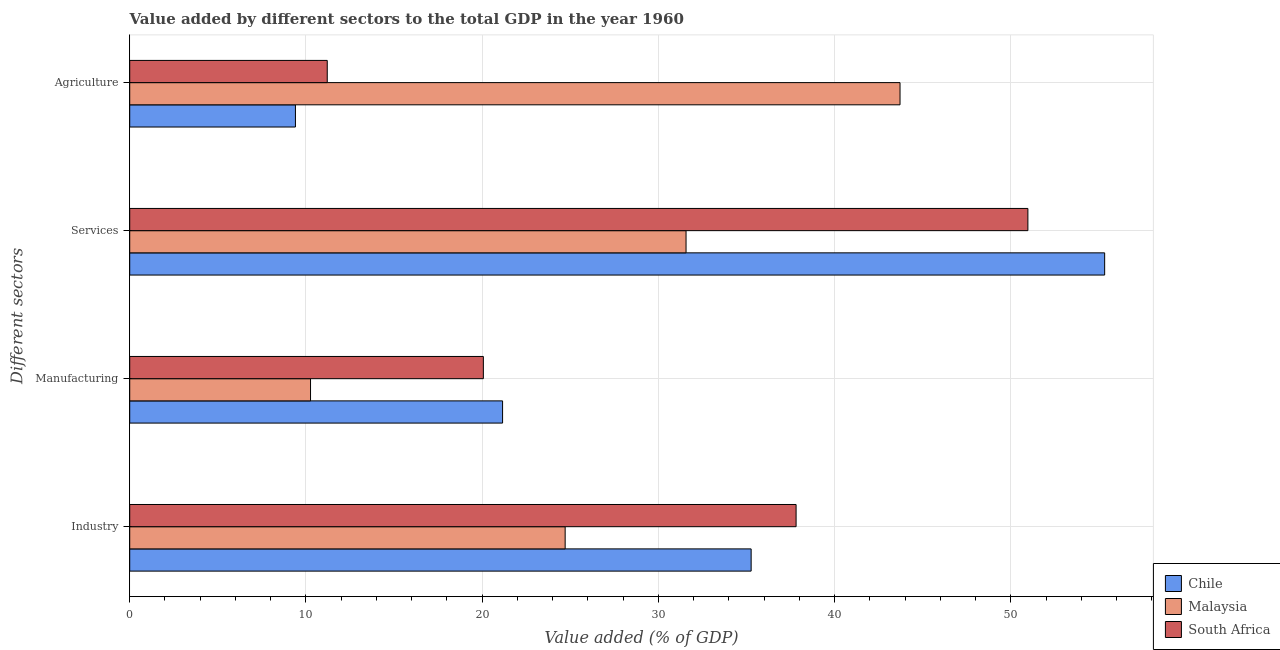How many different coloured bars are there?
Make the answer very short. 3. How many groups of bars are there?
Make the answer very short. 4. Are the number of bars on each tick of the Y-axis equal?
Offer a terse response. Yes. How many bars are there on the 3rd tick from the top?
Your answer should be very brief. 3. How many bars are there on the 4th tick from the bottom?
Provide a succinct answer. 3. What is the label of the 2nd group of bars from the top?
Ensure brevity in your answer.  Services. What is the value added by agricultural sector in Chile?
Make the answer very short. 9.4. Across all countries, what is the maximum value added by services sector?
Your answer should be compact. 55.33. Across all countries, what is the minimum value added by manufacturing sector?
Give a very brief answer. 10.26. In which country was the value added by agricultural sector maximum?
Provide a short and direct response. Malaysia. What is the total value added by manufacturing sector in the graph?
Keep it short and to the point. 51.49. What is the difference between the value added by manufacturing sector in Chile and that in Malaysia?
Your answer should be compact. 10.9. What is the difference between the value added by industrial sector in Malaysia and the value added by manufacturing sector in South Africa?
Provide a short and direct response. 4.64. What is the average value added by services sector per country?
Offer a terse response. 45.96. What is the difference between the value added by industrial sector and value added by agricultural sector in Malaysia?
Ensure brevity in your answer.  -19. In how many countries, is the value added by industrial sector greater than 48 %?
Provide a short and direct response. 0. What is the ratio of the value added by services sector in Chile to that in South Africa?
Make the answer very short. 1.09. Is the difference between the value added by manufacturing sector in South Africa and Malaysia greater than the difference between the value added by industrial sector in South Africa and Malaysia?
Provide a succinct answer. No. What is the difference between the highest and the second highest value added by agricultural sector?
Offer a terse response. 32.51. What is the difference between the highest and the lowest value added by services sector?
Make the answer very short. 23.76. Is the sum of the value added by agricultural sector in Malaysia and South Africa greater than the maximum value added by industrial sector across all countries?
Your response must be concise. Yes. What does the 3rd bar from the bottom in Services represents?
Keep it short and to the point. South Africa. Is it the case that in every country, the sum of the value added by industrial sector and value added by manufacturing sector is greater than the value added by services sector?
Make the answer very short. Yes. How many bars are there?
Keep it short and to the point. 12. Are all the bars in the graph horizontal?
Keep it short and to the point. Yes. How many countries are there in the graph?
Your response must be concise. 3. Does the graph contain grids?
Make the answer very short. Yes. How many legend labels are there?
Ensure brevity in your answer.  3. What is the title of the graph?
Ensure brevity in your answer.  Value added by different sectors to the total GDP in the year 1960. Does "Switzerland" appear as one of the legend labels in the graph?
Offer a very short reply. No. What is the label or title of the X-axis?
Ensure brevity in your answer.  Value added (% of GDP). What is the label or title of the Y-axis?
Keep it short and to the point. Different sectors. What is the Value added (% of GDP) in Chile in Industry?
Offer a very short reply. 35.27. What is the Value added (% of GDP) of Malaysia in Industry?
Your answer should be very brief. 24.71. What is the Value added (% of GDP) in South Africa in Industry?
Make the answer very short. 37.82. What is the Value added (% of GDP) in Chile in Manufacturing?
Your response must be concise. 21.16. What is the Value added (% of GDP) in Malaysia in Manufacturing?
Ensure brevity in your answer.  10.26. What is the Value added (% of GDP) in South Africa in Manufacturing?
Make the answer very short. 20.07. What is the Value added (% of GDP) of Chile in Services?
Offer a very short reply. 55.33. What is the Value added (% of GDP) in Malaysia in Services?
Provide a short and direct response. 31.57. What is the Value added (% of GDP) in South Africa in Services?
Provide a succinct answer. 50.97. What is the Value added (% of GDP) of Chile in Agriculture?
Provide a succinct answer. 9.4. What is the Value added (% of GDP) of Malaysia in Agriculture?
Make the answer very short. 43.72. What is the Value added (% of GDP) in South Africa in Agriculture?
Your answer should be compact. 11.21. Across all Different sectors, what is the maximum Value added (% of GDP) in Chile?
Provide a succinct answer. 55.33. Across all Different sectors, what is the maximum Value added (% of GDP) in Malaysia?
Your response must be concise. 43.72. Across all Different sectors, what is the maximum Value added (% of GDP) of South Africa?
Your response must be concise. 50.97. Across all Different sectors, what is the minimum Value added (% of GDP) in Chile?
Make the answer very short. 9.4. Across all Different sectors, what is the minimum Value added (% of GDP) of Malaysia?
Provide a succinct answer. 10.26. Across all Different sectors, what is the minimum Value added (% of GDP) in South Africa?
Offer a terse response. 11.21. What is the total Value added (% of GDP) in Chile in the graph?
Your answer should be very brief. 121.16. What is the total Value added (% of GDP) of Malaysia in the graph?
Your answer should be very brief. 110.26. What is the total Value added (% of GDP) in South Africa in the graph?
Keep it short and to the point. 120.07. What is the difference between the Value added (% of GDP) in Chile in Industry and that in Manufacturing?
Keep it short and to the point. 14.11. What is the difference between the Value added (% of GDP) in Malaysia in Industry and that in Manufacturing?
Ensure brevity in your answer.  14.45. What is the difference between the Value added (% of GDP) of South Africa in Industry and that in Manufacturing?
Offer a terse response. 17.75. What is the difference between the Value added (% of GDP) of Chile in Industry and that in Services?
Your response must be concise. -20.06. What is the difference between the Value added (% of GDP) in Malaysia in Industry and that in Services?
Provide a succinct answer. -6.86. What is the difference between the Value added (% of GDP) in South Africa in Industry and that in Services?
Your answer should be very brief. -13.15. What is the difference between the Value added (% of GDP) of Chile in Industry and that in Agriculture?
Provide a succinct answer. 25.86. What is the difference between the Value added (% of GDP) of Malaysia in Industry and that in Agriculture?
Your answer should be compact. -19. What is the difference between the Value added (% of GDP) in South Africa in Industry and that in Agriculture?
Offer a terse response. 26.61. What is the difference between the Value added (% of GDP) in Chile in Manufacturing and that in Services?
Your answer should be compact. -34.17. What is the difference between the Value added (% of GDP) in Malaysia in Manufacturing and that in Services?
Ensure brevity in your answer.  -21.31. What is the difference between the Value added (% of GDP) in South Africa in Manufacturing and that in Services?
Offer a terse response. -30.9. What is the difference between the Value added (% of GDP) of Chile in Manufacturing and that in Agriculture?
Offer a terse response. 11.76. What is the difference between the Value added (% of GDP) of Malaysia in Manufacturing and that in Agriculture?
Ensure brevity in your answer.  -33.45. What is the difference between the Value added (% of GDP) in South Africa in Manufacturing and that in Agriculture?
Give a very brief answer. 8.86. What is the difference between the Value added (% of GDP) in Chile in Services and that in Agriculture?
Provide a succinct answer. 45.92. What is the difference between the Value added (% of GDP) of Malaysia in Services and that in Agriculture?
Your response must be concise. -12.14. What is the difference between the Value added (% of GDP) in South Africa in Services and that in Agriculture?
Give a very brief answer. 39.76. What is the difference between the Value added (% of GDP) in Chile in Industry and the Value added (% of GDP) in Malaysia in Manufacturing?
Your answer should be compact. 25.01. What is the difference between the Value added (% of GDP) of Chile in Industry and the Value added (% of GDP) of South Africa in Manufacturing?
Keep it short and to the point. 15.2. What is the difference between the Value added (% of GDP) of Malaysia in Industry and the Value added (% of GDP) of South Africa in Manufacturing?
Ensure brevity in your answer.  4.64. What is the difference between the Value added (% of GDP) in Chile in Industry and the Value added (% of GDP) in Malaysia in Services?
Your answer should be very brief. 3.69. What is the difference between the Value added (% of GDP) in Chile in Industry and the Value added (% of GDP) in South Africa in Services?
Give a very brief answer. -15.71. What is the difference between the Value added (% of GDP) in Malaysia in Industry and the Value added (% of GDP) in South Africa in Services?
Provide a succinct answer. -26.26. What is the difference between the Value added (% of GDP) of Chile in Industry and the Value added (% of GDP) of Malaysia in Agriculture?
Make the answer very short. -8.45. What is the difference between the Value added (% of GDP) of Chile in Industry and the Value added (% of GDP) of South Africa in Agriculture?
Keep it short and to the point. 24.06. What is the difference between the Value added (% of GDP) in Malaysia in Industry and the Value added (% of GDP) in South Africa in Agriculture?
Offer a very short reply. 13.5. What is the difference between the Value added (% of GDP) of Chile in Manufacturing and the Value added (% of GDP) of Malaysia in Services?
Offer a very short reply. -10.41. What is the difference between the Value added (% of GDP) in Chile in Manufacturing and the Value added (% of GDP) in South Africa in Services?
Your response must be concise. -29.81. What is the difference between the Value added (% of GDP) in Malaysia in Manufacturing and the Value added (% of GDP) in South Africa in Services?
Offer a very short reply. -40.71. What is the difference between the Value added (% of GDP) in Chile in Manufacturing and the Value added (% of GDP) in Malaysia in Agriculture?
Make the answer very short. -22.56. What is the difference between the Value added (% of GDP) in Chile in Manufacturing and the Value added (% of GDP) in South Africa in Agriculture?
Offer a very short reply. 9.95. What is the difference between the Value added (% of GDP) in Malaysia in Manufacturing and the Value added (% of GDP) in South Africa in Agriculture?
Give a very brief answer. -0.95. What is the difference between the Value added (% of GDP) of Chile in Services and the Value added (% of GDP) of Malaysia in Agriculture?
Offer a terse response. 11.61. What is the difference between the Value added (% of GDP) of Chile in Services and the Value added (% of GDP) of South Africa in Agriculture?
Your response must be concise. 44.12. What is the difference between the Value added (% of GDP) of Malaysia in Services and the Value added (% of GDP) of South Africa in Agriculture?
Your answer should be very brief. 20.36. What is the average Value added (% of GDP) in Chile per Different sectors?
Give a very brief answer. 30.29. What is the average Value added (% of GDP) in Malaysia per Different sectors?
Offer a very short reply. 27.57. What is the average Value added (% of GDP) in South Africa per Different sectors?
Keep it short and to the point. 30.02. What is the difference between the Value added (% of GDP) of Chile and Value added (% of GDP) of Malaysia in Industry?
Keep it short and to the point. 10.56. What is the difference between the Value added (% of GDP) in Chile and Value added (% of GDP) in South Africa in Industry?
Give a very brief answer. -2.55. What is the difference between the Value added (% of GDP) of Malaysia and Value added (% of GDP) of South Africa in Industry?
Your answer should be compact. -13.11. What is the difference between the Value added (% of GDP) of Chile and Value added (% of GDP) of Malaysia in Manufacturing?
Give a very brief answer. 10.9. What is the difference between the Value added (% of GDP) in Chile and Value added (% of GDP) in South Africa in Manufacturing?
Your response must be concise. 1.09. What is the difference between the Value added (% of GDP) of Malaysia and Value added (% of GDP) of South Africa in Manufacturing?
Your response must be concise. -9.81. What is the difference between the Value added (% of GDP) of Chile and Value added (% of GDP) of Malaysia in Services?
Your response must be concise. 23.76. What is the difference between the Value added (% of GDP) of Chile and Value added (% of GDP) of South Africa in Services?
Make the answer very short. 4.36. What is the difference between the Value added (% of GDP) of Malaysia and Value added (% of GDP) of South Africa in Services?
Ensure brevity in your answer.  -19.4. What is the difference between the Value added (% of GDP) of Chile and Value added (% of GDP) of Malaysia in Agriculture?
Your answer should be very brief. -34.31. What is the difference between the Value added (% of GDP) in Chile and Value added (% of GDP) in South Africa in Agriculture?
Provide a succinct answer. -1.81. What is the difference between the Value added (% of GDP) of Malaysia and Value added (% of GDP) of South Africa in Agriculture?
Your response must be concise. 32.51. What is the ratio of the Value added (% of GDP) in Malaysia in Industry to that in Manufacturing?
Offer a terse response. 2.41. What is the ratio of the Value added (% of GDP) of South Africa in Industry to that in Manufacturing?
Ensure brevity in your answer.  1.88. What is the ratio of the Value added (% of GDP) in Chile in Industry to that in Services?
Make the answer very short. 0.64. What is the ratio of the Value added (% of GDP) in Malaysia in Industry to that in Services?
Offer a terse response. 0.78. What is the ratio of the Value added (% of GDP) in South Africa in Industry to that in Services?
Provide a short and direct response. 0.74. What is the ratio of the Value added (% of GDP) of Chile in Industry to that in Agriculture?
Keep it short and to the point. 3.75. What is the ratio of the Value added (% of GDP) in Malaysia in Industry to that in Agriculture?
Keep it short and to the point. 0.57. What is the ratio of the Value added (% of GDP) of South Africa in Industry to that in Agriculture?
Provide a short and direct response. 3.37. What is the ratio of the Value added (% of GDP) of Chile in Manufacturing to that in Services?
Your answer should be compact. 0.38. What is the ratio of the Value added (% of GDP) of Malaysia in Manufacturing to that in Services?
Give a very brief answer. 0.33. What is the ratio of the Value added (% of GDP) in South Africa in Manufacturing to that in Services?
Ensure brevity in your answer.  0.39. What is the ratio of the Value added (% of GDP) of Chile in Manufacturing to that in Agriculture?
Give a very brief answer. 2.25. What is the ratio of the Value added (% of GDP) in Malaysia in Manufacturing to that in Agriculture?
Provide a short and direct response. 0.23. What is the ratio of the Value added (% of GDP) in South Africa in Manufacturing to that in Agriculture?
Make the answer very short. 1.79. What is the ratio of the Value added (% of GDP) of Chile in Services to that in Agriculture?
Offer a terse response. 5.88. What is the ratio of the Value added (% of GDP) of Malaysia in Services to that in Agriculture?
Give a very brief answer. 0.72. What is the ratio of the Value added (% of GDP) of South Africa in Services to that in Agriculture?
Give a very brief answer. 4.55. What is the difference between the highest and the second highest Value added (% of GDP) in Chile?
Make the answer very short. 20.06. What is the difference between the highest and the second highest Value added (% of GDP) in Malaysia?
Your answer should be very brief. 12.14. What is the difference between the highest and the second highest Value added (% of GDP) of South Africa?
Keep it short and to the point. 13.15. What is the difference between the highest and the lowest Value added (% of GDP) in Chile?
Your answer should be very brief. 45.92. What is the difference between the highest and the lowest Value added (% of GDP) of Malaysia?
Keep it short and to the point. 33.45. What is the difference between the highest and the lowest Value added (% of GDP) of South Africa?
Provide a succinct answer. 39.76. 